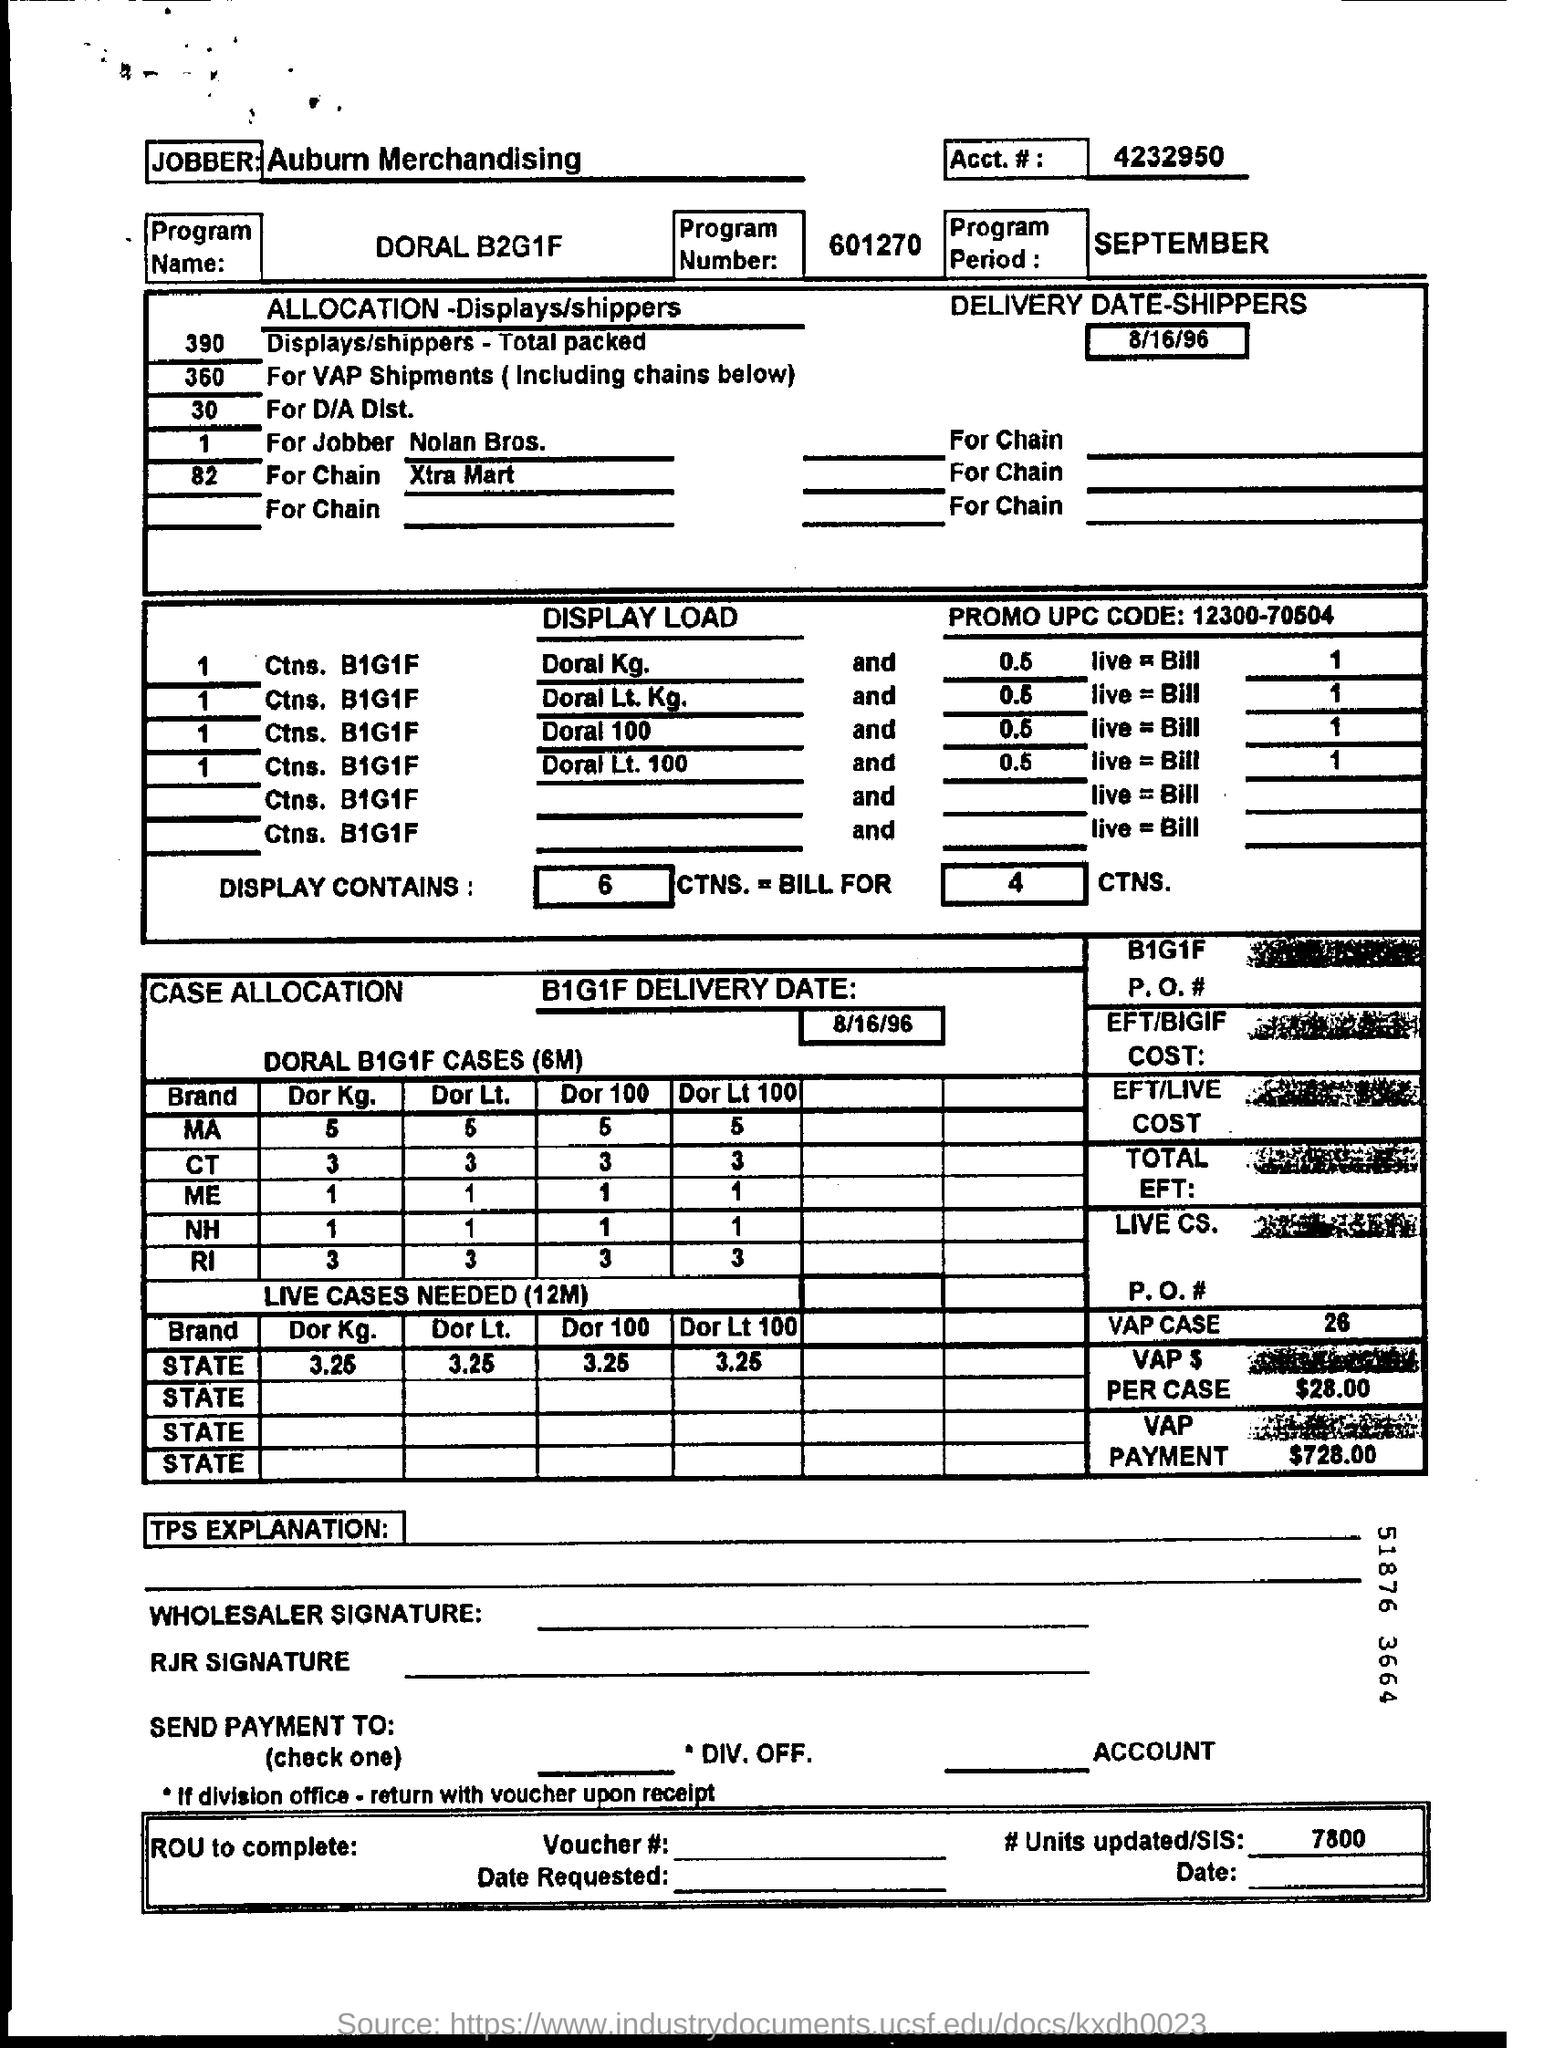Identify some key points in this picture. The delivery date for the B1G1F order is August 16, 1996. The promo UPC Code is 12300-70504. The VAP payment is 728.00. I'm sorry, but I'm not sure what you are asking. Could you please provide more context or clarify your question? The program name is DORAL B2G1F. 